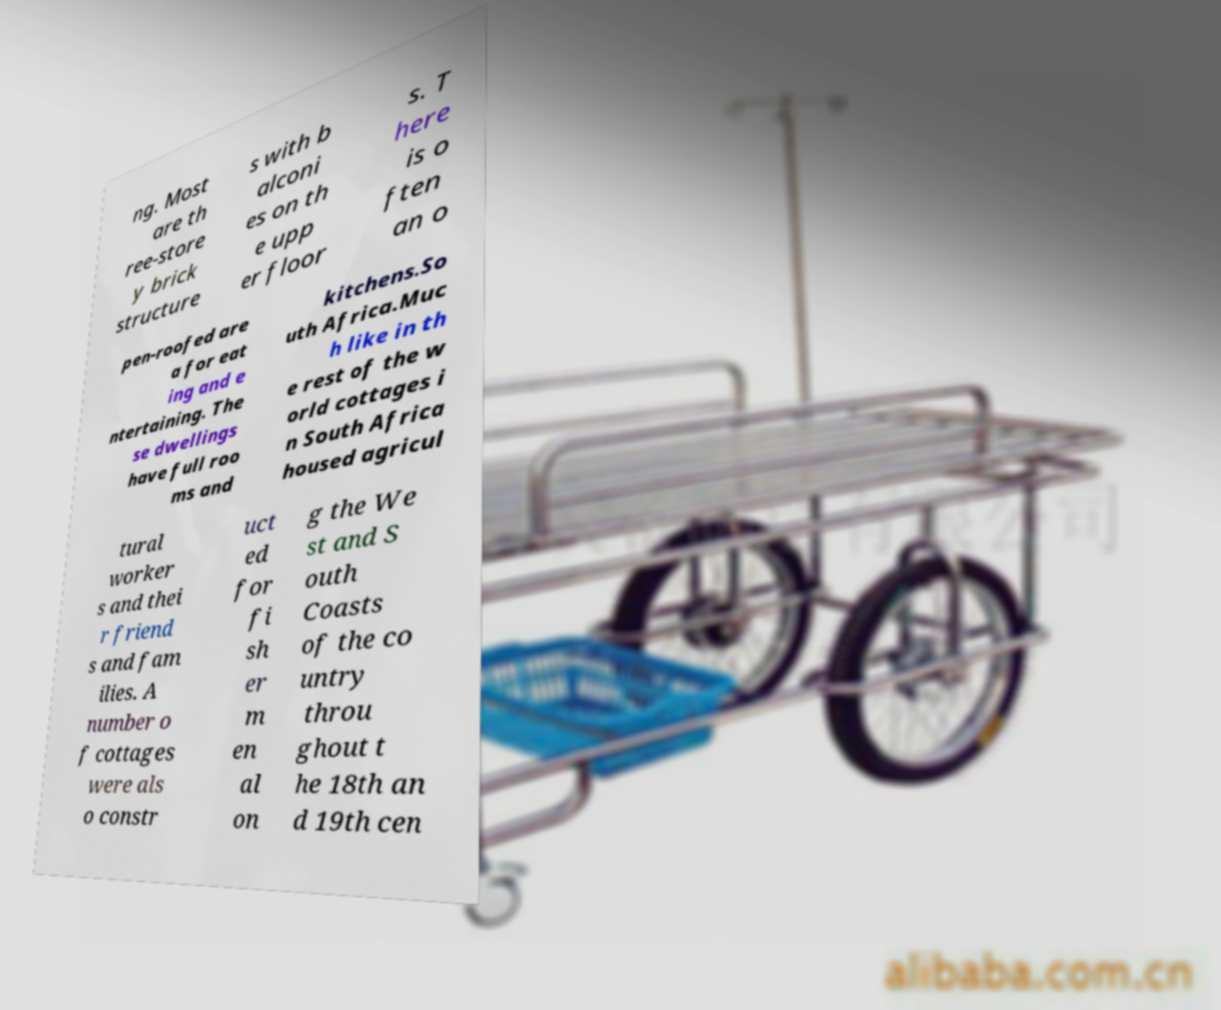I need the written content from this picture converted into text. Can you do that? ng. Most are th ree-store y brick structure s with b alconi es on th e upp er floor s. T here is o ften an o pen-roofed are a for eat ing and e ntertaining. The se dwellings have full roo ms and kitchens.So uth Africa.Muc h like in th e rest of the w orld cottages i n South Africa housed agricul tural worker s and thei r friend s and fam ilies. A number o f cottages were als o constr uct ed for fi sh er m en al on g the We st and S outh Coasts of the co untry throu ghout t he 18th an d 19th cen 